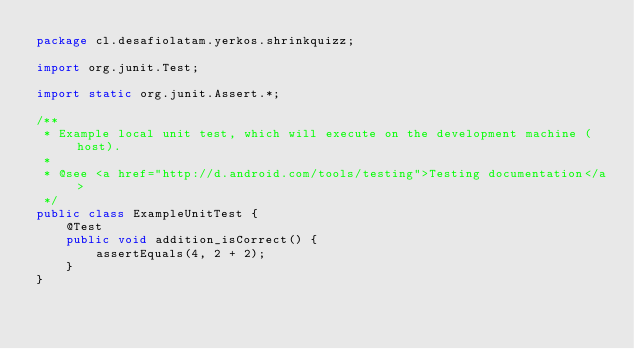<code> <loc_0><loc_0><loc_500><loc_500><_Java_>package cl.desafiolatam.yerkos.shrinkquizz;

import org.junit.Test;

import static org.junit.Assert.*;

/**
 * Example local unit test, which will execute on the development machine (host).
 *
 * @see <a href="http://d.android.com/tools/testing">Testing documentation</a>
 */
public class ExampleUnitTest {
    @Test
    public void addition_isCorrect() {
        assertEquals(4, 2 + 2);
    }
}</code> 